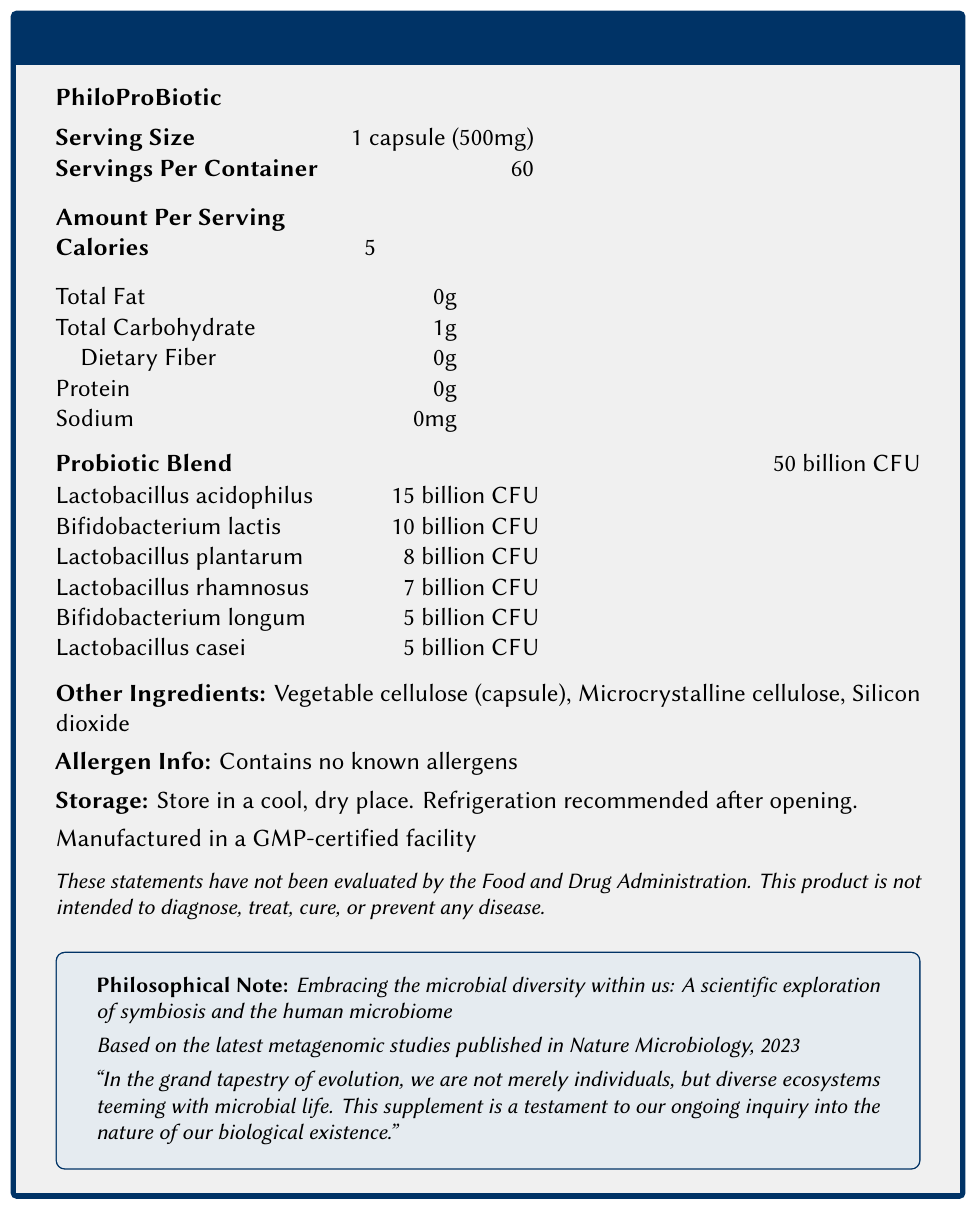what is the product name? The product name is provided at the beginning of the document and is highlighted in bold.
Answer: PhiloProBiotic what is the serving size for PhiloProBiotic? The serving size is explicitly stated in the document's nutritional information section.
Answer: 1 capsule (500mg) how many CFUs are in one serving of the probiotic blend? The document states that the Probiotic Blend contains 50 billion CFU per serving.
Answer: 50 billion CFU how many strains are included in the Probiotic Blend? The document lists six different strains of probiotics under the Probiotic Blend section.
Answer: 6 which probiotic strain has the highest CFU count? The Lactobacillus acidophilus strain is listed with 15 billion CFU, which is the highest among the listed strains.
Answer: Lactobacillus acidophilus what are the primary ingredients in the PhiloProBiotic supplement? The document lists these ingredients under the "Other Ingredients" section.
Answer: Vegetable cellulose (capsule), Microcrystalline cellulose, Silicon dioxide does the PhiloProBiotic contain any known allergens? The document explicitly states that the product "contains no known allergens."
Answer: No how many calories are present in one serving? The document lists the calorie content of one serving as 5 calories.
Answer: 5 what is the storage recommendation for PhiloProBiotic? A. Store in a refrigerator always B. Store in a cool, dry place only C. Store in a cool, dry place, and refrigeration recommended after opening D. No special storage required The document specifies: "Store in a cool, dry place. Refrigeration recommended after opening."
Answer: C which strain is listed with 10 billion CFU? A. Lactobacillus acidophilus B. Lactobacillus rhamnosus C. Bifidobacterium longum D. Bifidobacterium lactis The document states that Bifidobacterium lactis has 10 billion CFU.
Answer: D does the PhiloProBiotic supplement contain any sodium? The document specifies that the sodium content per serving is 0mg.
Answer: No how many servings are there per container? The document states that there are 60 servings per container.
Answer: 60 can we determine the flavor of the PhiloProBiotic supplement from the document? The document does not provide any information about the flavor of the supplement.
Answer: Cannot be determined summarize the main idea of the PhiloProBiotic Nutrition Facts Label. The document provides detailed nutritional information about the PhiloProBiotic supplement, including serving size, CFU composition, storage instructions, and allergen information, while emphasizing its contribution to microbial diversity and human health.
Answer: The PhiloProBiotic is a dietary supplement containing various probiotic strains with a total of 50 billion CFU per serving. It includes six different probiotic strains, each with a specific CFU count. The supplement contains no known allergens and has a minimal calorie count per serving. It is recommended to be stored in a cool, dry place with refrigeration suggested after opening. which strain has the lowest CFU count? Both Bifidobacterium longum and Lactobacillus casei have 5 billion CFU each, which is the lowest CFU count among the listed strains.
Answer: Bifidobacterium longum and Lactobacillus casei 